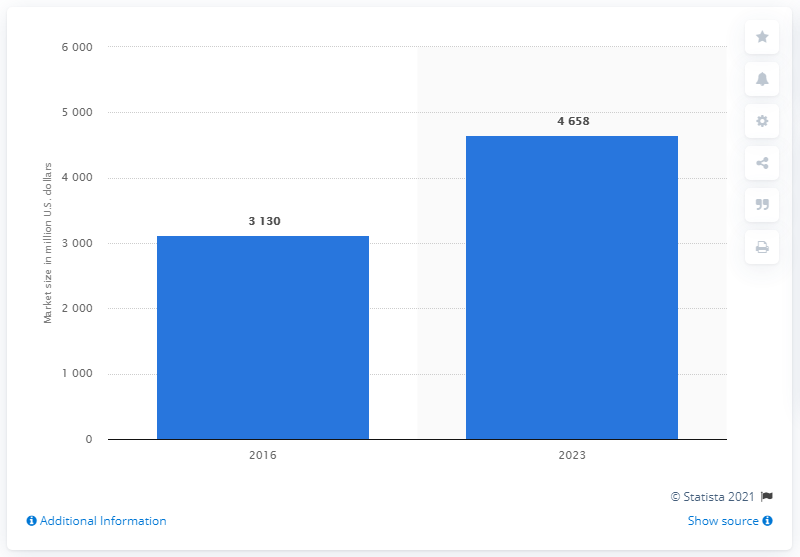How much is the market expected to grow by 2023?
 4658 